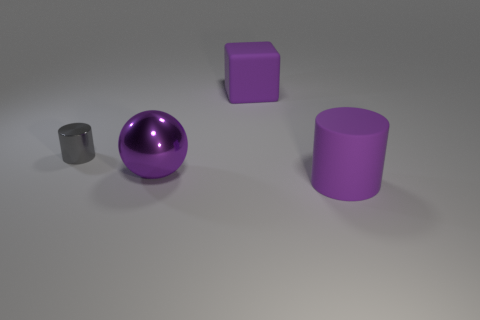Are there any cyan shiny blocks that have the same size as the matte cylinder? no 